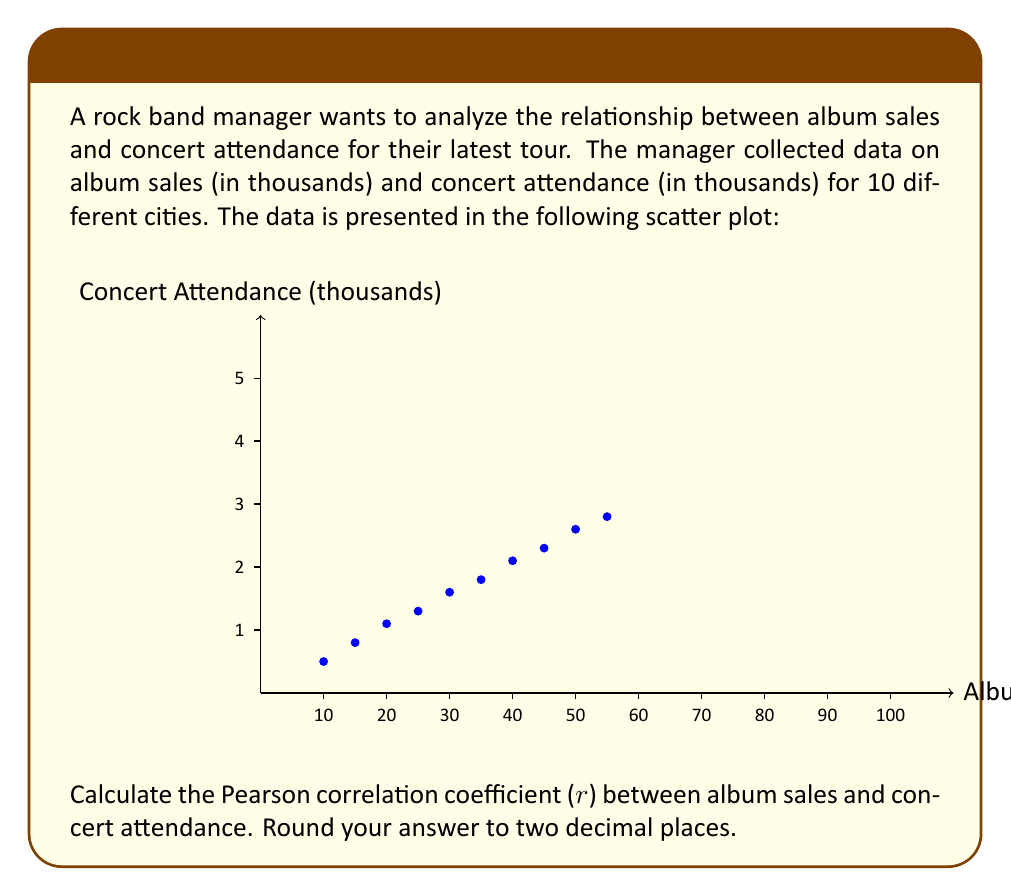Help me with this question. To calculate the Pearson correlation coefficient (r), we'll use the formula:

$$ r = \frac{\sum_{i=1}^{n} (x_i - \bar{x})(y_i - \bar{y})}{\sqrt{\sum_{i=1}^{n} (x_i - \bar{x})^2 \sum_{i=1}^{n} (y_i - \bar{y})^2}} $$

Where:
$x_i$ = album sales for city i
$y_i$ = concert attendance for city i
$\bar{x}$ = mean of album sales
$\bar{y}$ = mean of concert attendance
n = number of cities (10)

Step 1: Calculate means
$\bar{x} = \frac{10+15+20+25+30+35+40+45+50+55}{10} = 32.5$
$\bar{y} = \frac{5+8+11+13+16+18+21+23+26+28}{10} = 16.9$

Step 2: Calculate $(x_i - \bar{x})$, $(y_i - \bar{y})$, $(x_i - \bar{x})^2$, $(y_i - \bar{y})^2$, and $(x_i - \bar{x})(y_i - \bar{y})$ for each city.

Step 3: Sum up the values calculated in Step 2:
$\sum (x_i - \bar{x})(y_i - \bar{y}) = 1282.5$
$\sum (x_i - \bar{x})^2 = 2062.5$
$\sum (y_i - \bar{y})^2 = 361.9$

Step 4: Apply the formula:

$$ r = \frac{1282.5}{\sqrt{2062.5 \times 361.9}} = \frac{1282.5}{863.01} = 0.9861 $$

Step 5: Round to two decimal places: 0.99
Answer: 0.99 